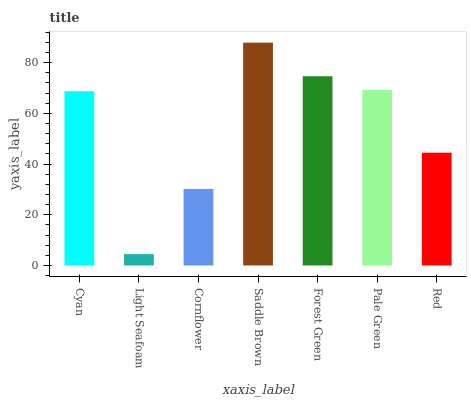Is Light Seafoam the minimum?
Answer yes or no. Yes. Is Saddle Brown the maximum?
Answer yes or no. Yes. Is Cornflower the minimum?
Answer yes or no. No. Is Cornflower the maximum?
Answer yes or no. No. Is Cornflower greater than Light Seafoam?
Answer yes or no. Yes. Is Light Seafoam less than Cornflower?
Answer yes or no. Yes. Is Light Seafoam greater than Cornflower?
Answer yes or no. No. Is Cornflower less than Light Seafoam?
Answer yes or no. No. Is Cyan the high median?
Answer yes or no. Yes. Is Cyan the low median?
Answer yes or no. Yes. Is Red the high median?
Answer yes or no. No. Is Light Seafoam the low median?
Answer yes or no. No. 